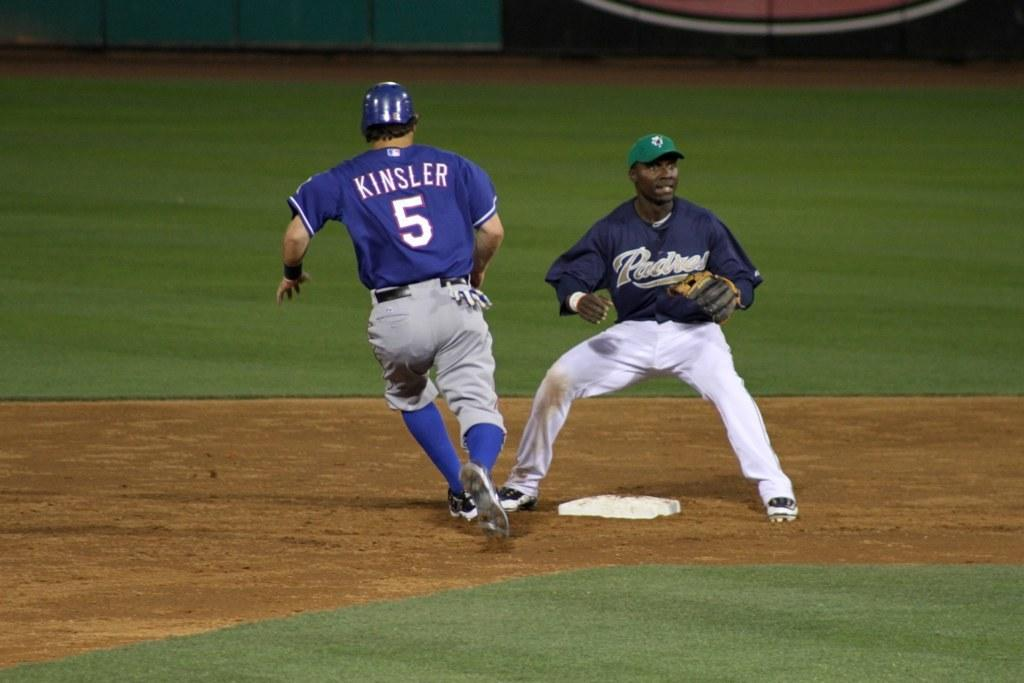<image>
Provide a brief description of the given image. a baseball player with the number 5 on their jersey 